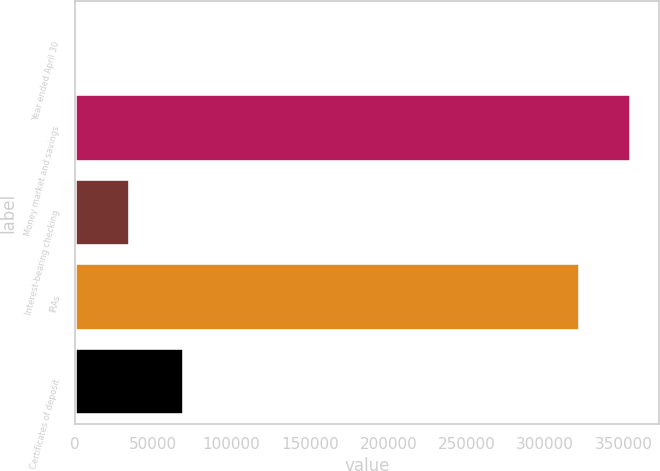Convert chart to OTSL. <chart><loc_0><loc_0><loc_500><loc_500><bar_chart><fcel>Year ended April 30<fcel>Money market and savings<fcel>Interest-bearing checking<fcel>IRAs<fcel>Certificates of deposit<nl><fcel>2013<fcel>355059<fcel>34993.6<fcel>322078<fcel>69444<nl></chart> 